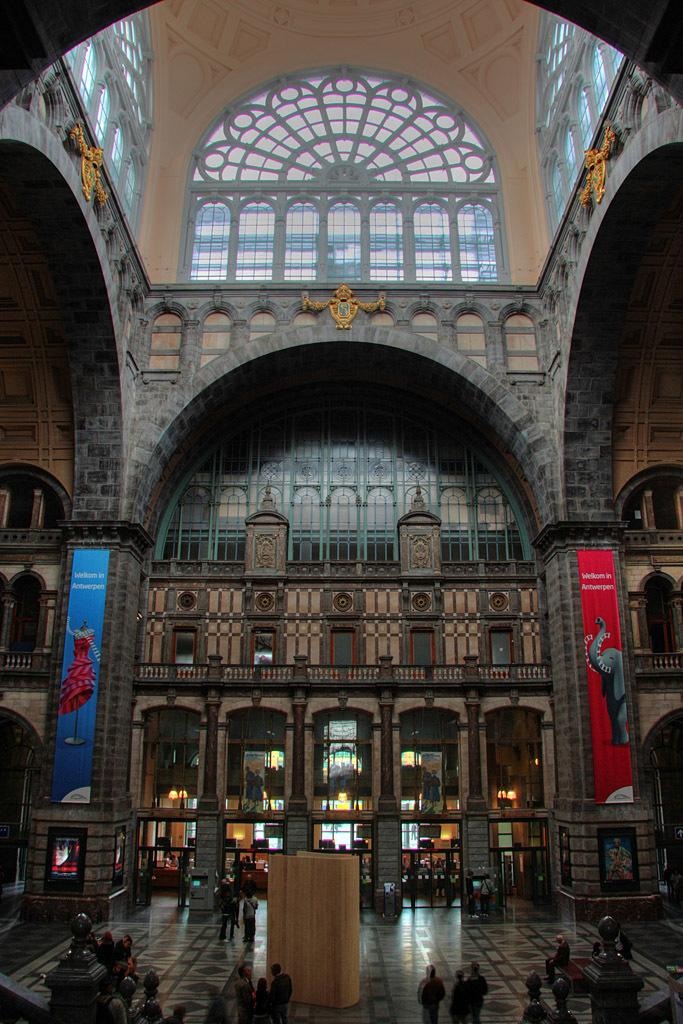What is the main structure in the image? There is a building in the image. What is happening in front of the building? There are people and an object in front of the building. Can you describe the building's features? The building has windows and pillars. What else can be seen in the image? There are boards with text and images in the image. What type of stitch is used to create the pattern on the basket in the image? There is no basket present in the image, so it is not possible to determine the type of stitch used. What color is the paint on the wall in the image? There is no mention of paint or a wall in the image, so it is not possible to determine the color of the paint. 